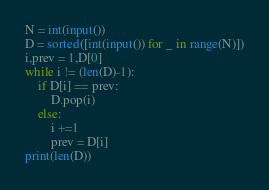<code> <loc_0><loc_0><loc_500><loc_500><_Python_>N = int(input())
D = sorted([int(input()) for _ in range(N)])
i,prev = 1,D[0]
while i != (len(D)-1):
    if D[i] == prev: 
        D.pop(i)
    else:
        i +=1
        prev = D[i]
print(len(D))</code> 